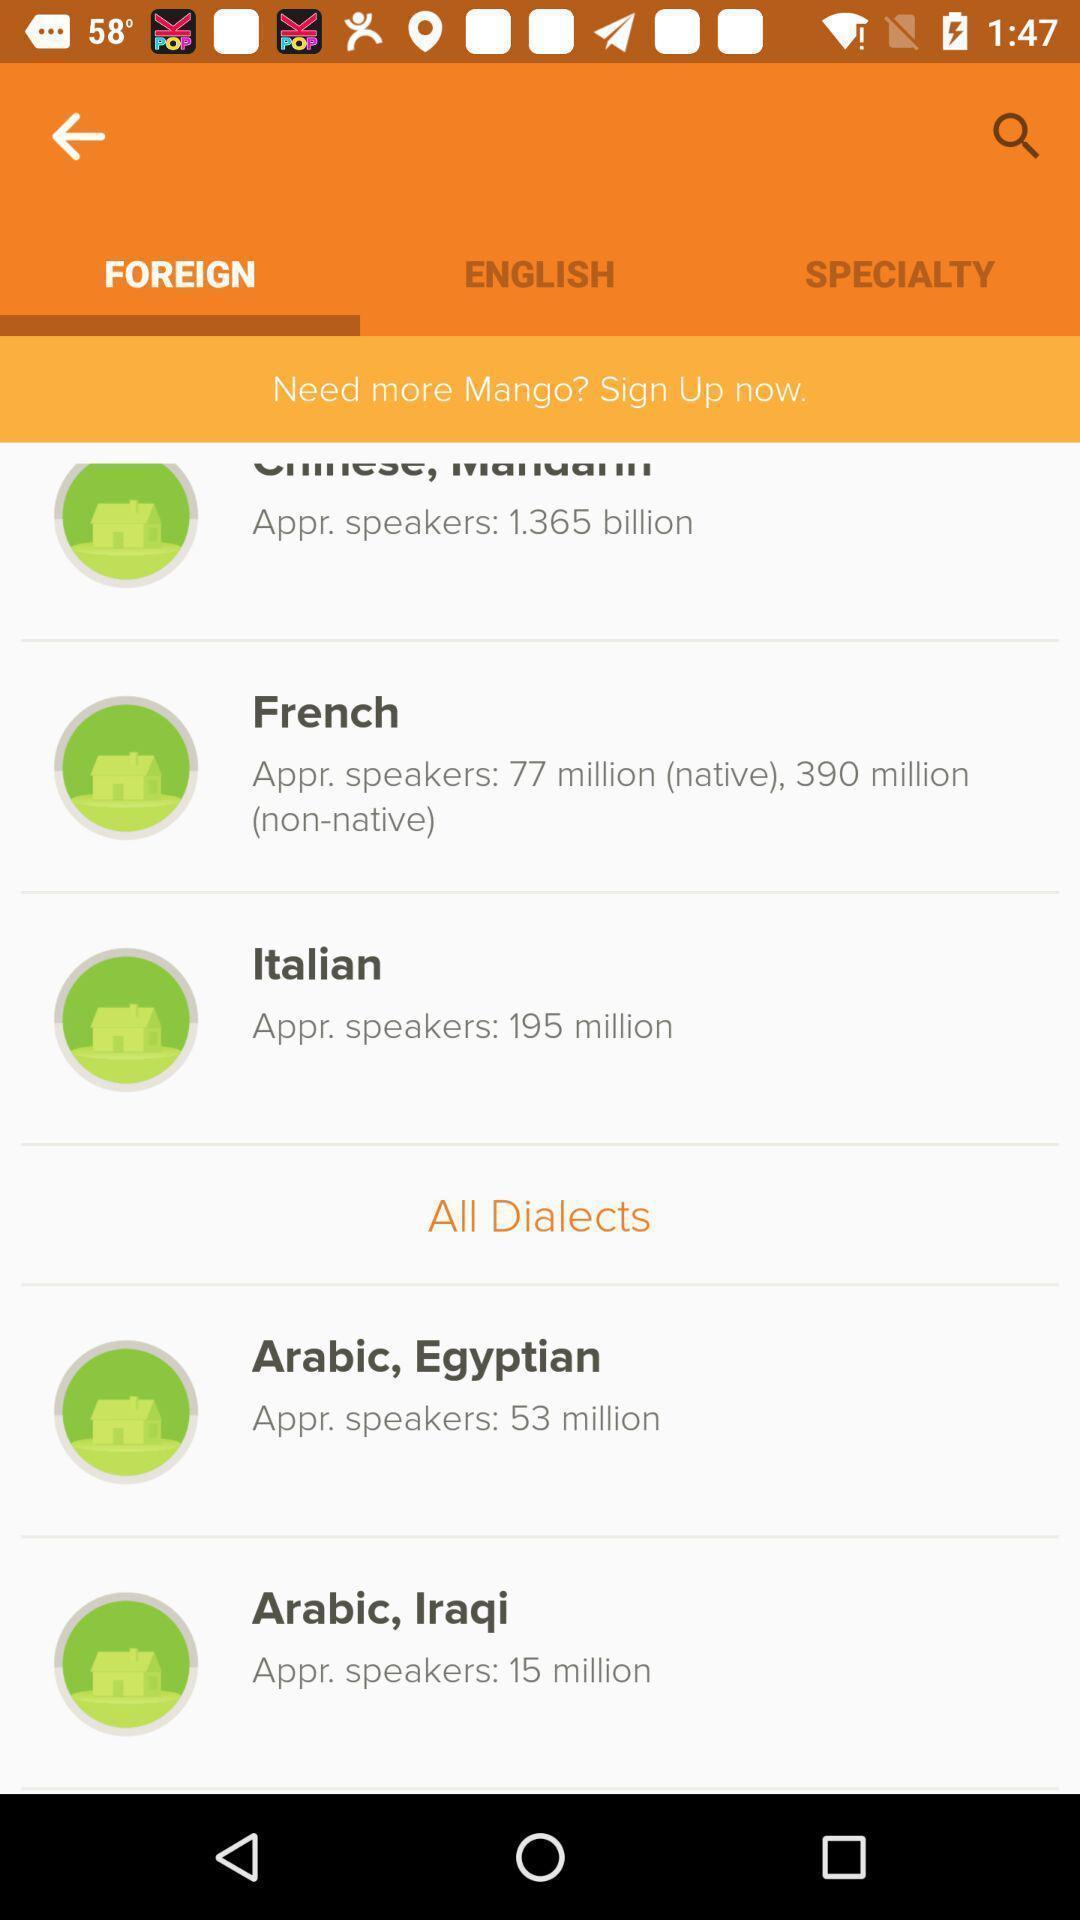Summarize the information in this screenshot. Page displaying the different types of languages. 